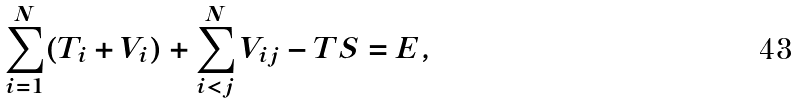<formula> <loc_0><loc_0><loc_500><loc_500>\sum _ { i = 1 } ^ { N } ( T _ { i } + V _ { i } ) + \sum _ { i < j } ^ { N } V _ { i j } - T S = E ,</formula> 